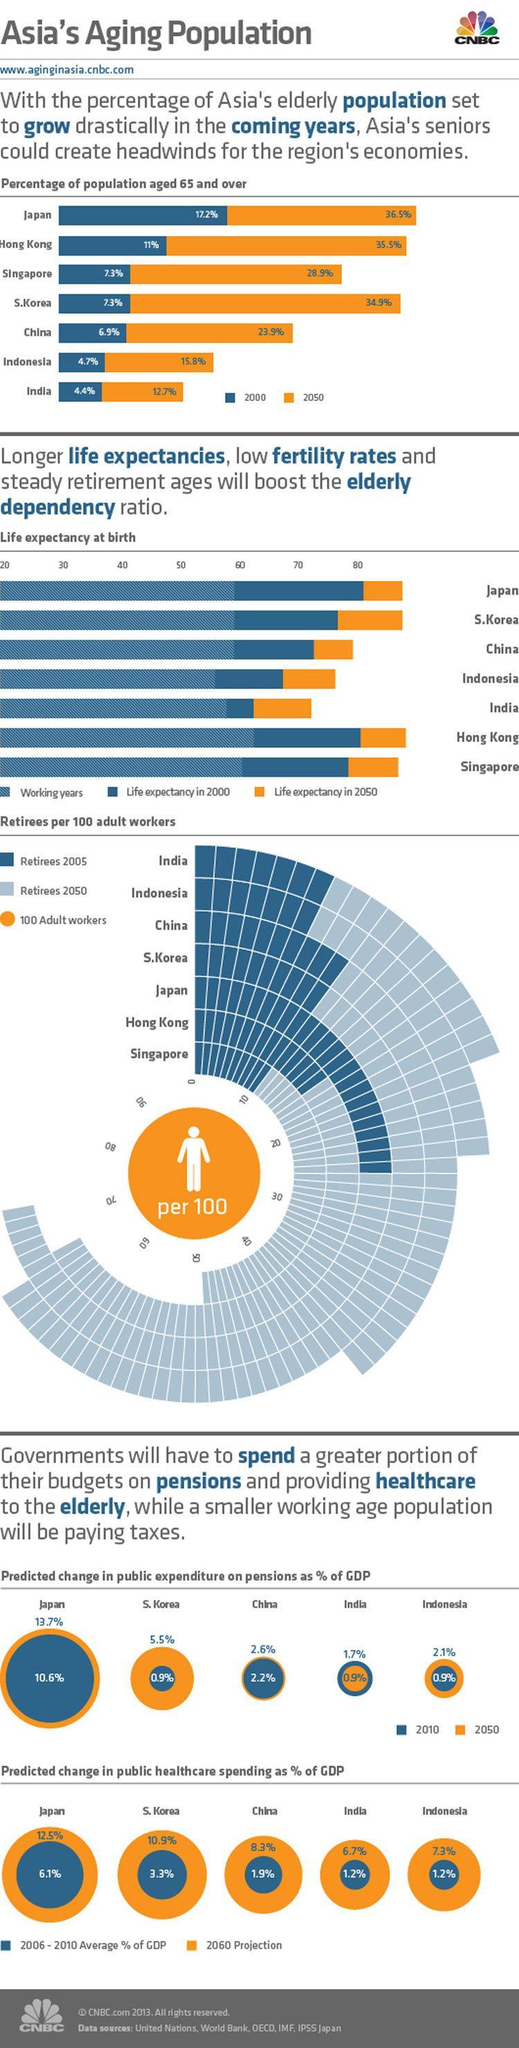What is the difference between the percentage of the population aged 65 and over in Japan in 2050 and 2000?
Answer the question with a short phrase. 19.3% What is the difference between the percentage of the population aged 65 and over in China in 2050 and 2000? 7% What is the difference between the percentage of the population aged 65 and over in Singapore in 2050 and 2000? 21.6% What is the difference between the percentage of the population aged 65 and over in Hong Kong in 2050 and 2000? 24.5% 